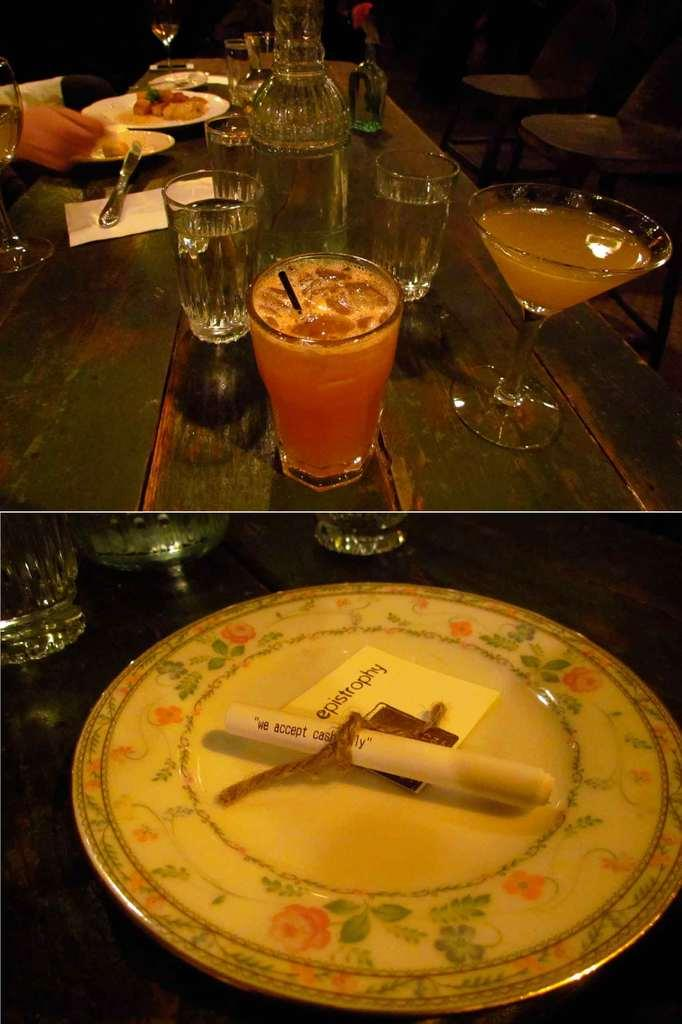What is on the table in the image? There is a glass, a paper, a spoon, a plate, food, a chain, an additional plate, and an additional paper on the table. What might be used for eating in the image? The spoon on the table might be used for eating. What is the purpose of the chain on the table? The purpose of the chain on the table is not clear from the image. What is the food on the table? The specific type of food on the table is not mentioned in the facts. What type of horn can be seen on the table in the image? There is no horn present on the table in the image. What color is the orange on the table in the image? There is no orange present on the table in the image. 